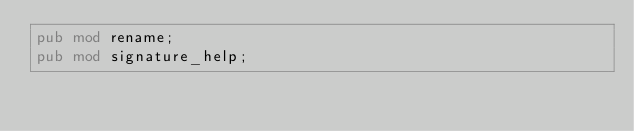<code> <loc_0><loc_0><loc_500><loc_500><_Rust_>pub mod rename;
pub mod signature_help;
</code> 